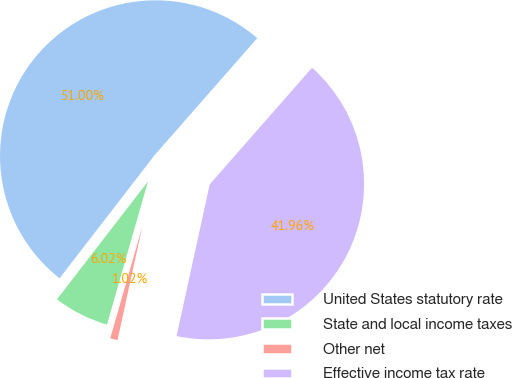<chart> <loc_0><loc_0><loc_500><loc_500><pie_chart><fcel>United States statutory rate<fcel>State and local income taxes<fcel>Other net<fcel>Effective income tax rate<nl><fcel>51.0%<fcel>6.02%<fcel>1.02%<fcel>41.96%<nl></chart> 